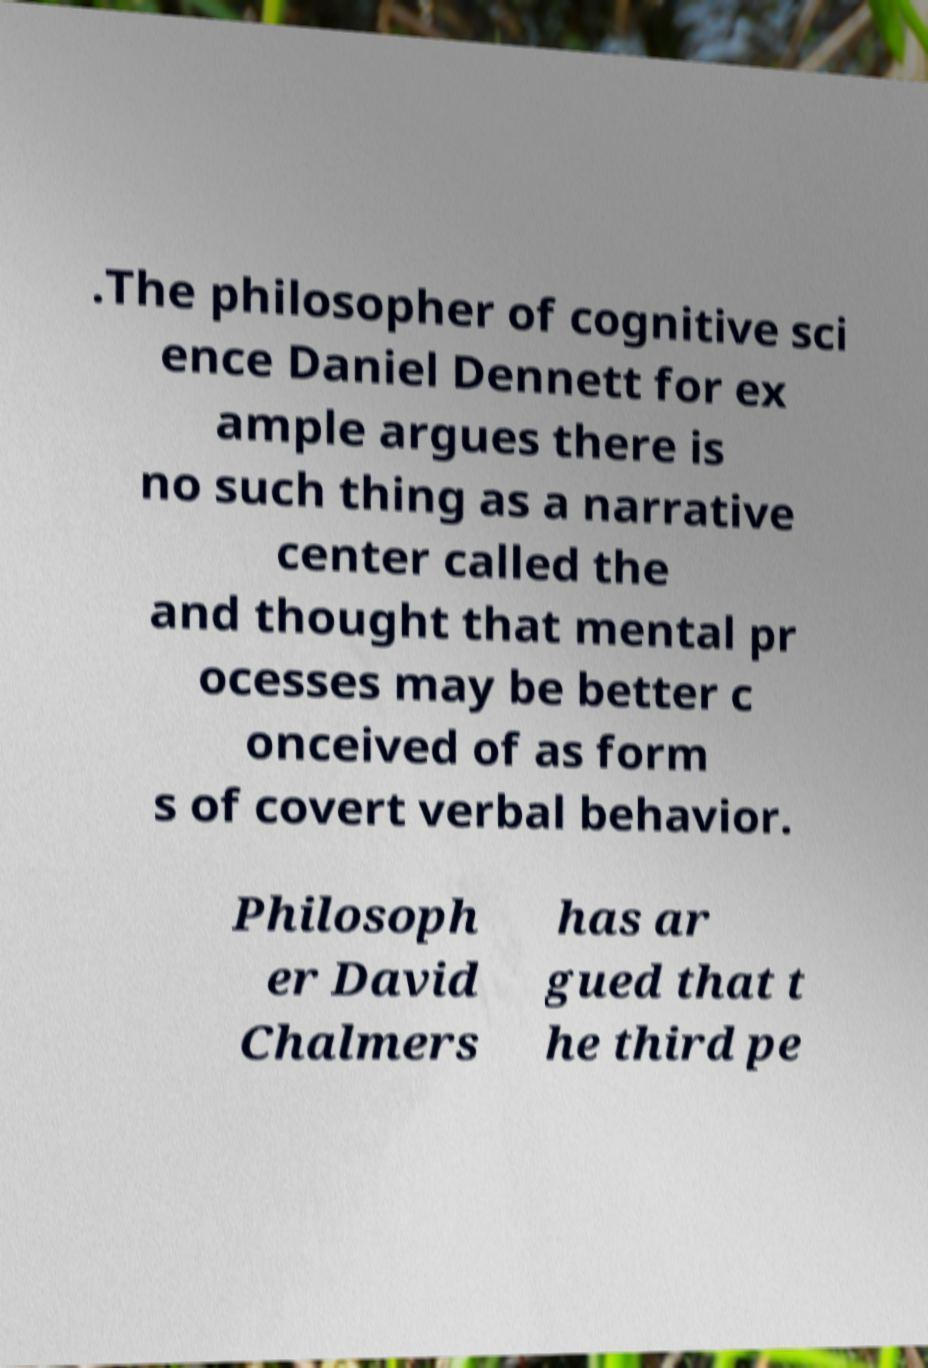For documentation purposes, I need the text within this image transcribed. Could you provide that? .The philosopher of cognitive sci ence Daniel Dennett for ex ample argues there is no such thing as a narrative center called the and thought that mental pr ocesses may be better c onceived of as form s of covert verbal behavior. Philosoph er David Chalmers has ar gued that t he third pe 